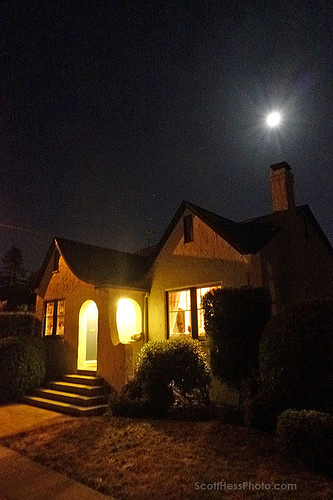<image>
Can you confirm if the roof is under the chimney? Yes. The roof is positioned underneath the chimney, with the chimney above it in the vertical space. 